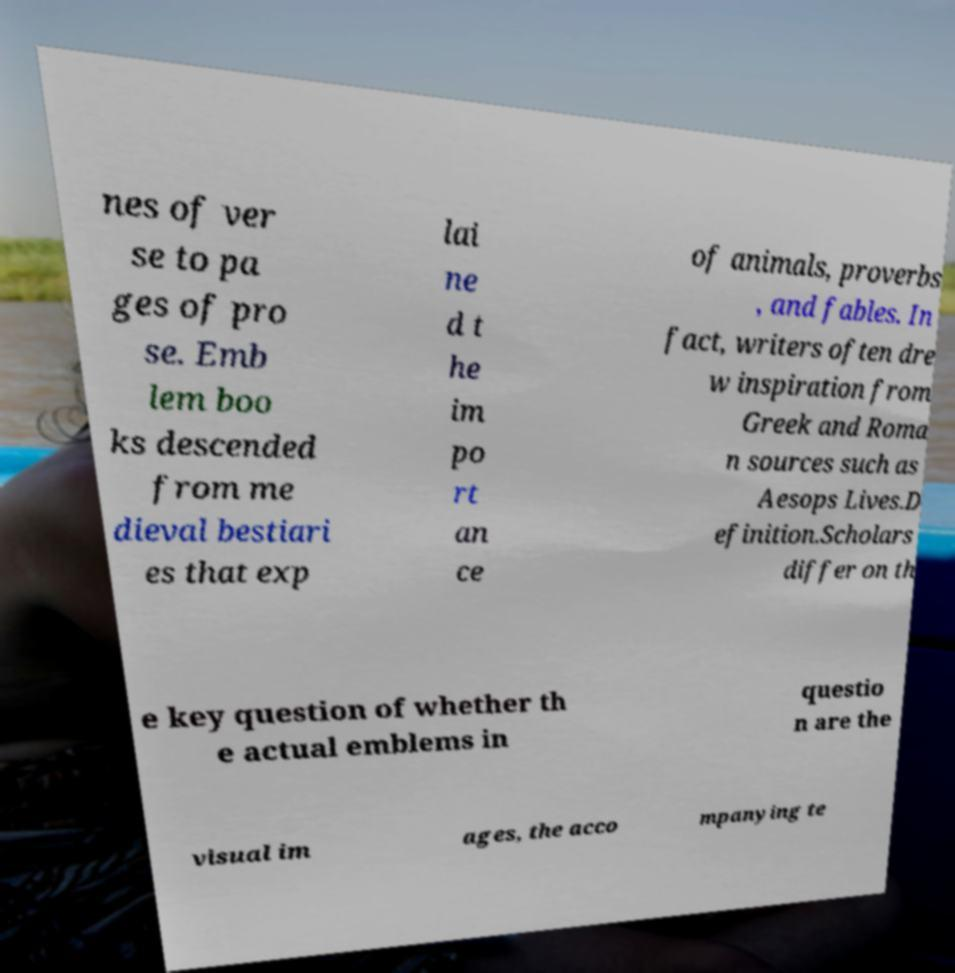Please read and relay the text visible in this image. What does it say? nes of ver se to pa ges of pro se. Emb lem boo ks descended from me dieval bestiari es that exp lai ne d t he im po rt an ce of animals, proverbs , and fables. In fact, writers often dre w inspiration from Greek and Roma n sources such as Aesops Lives.D efinition.Scholars differ on th e key question of whether th e actual emblems in questio n are the visual im ages, the acco mpanying te 